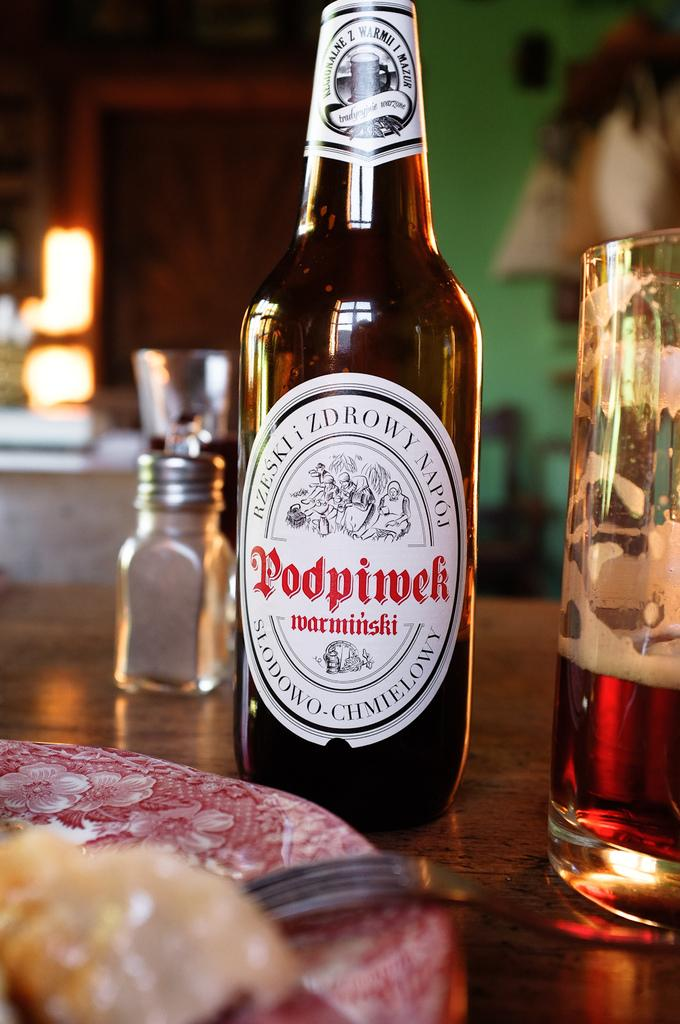Provide a one-sentence caption for the provided image. A glass of beer has been poured from a Podpimek bottle. 